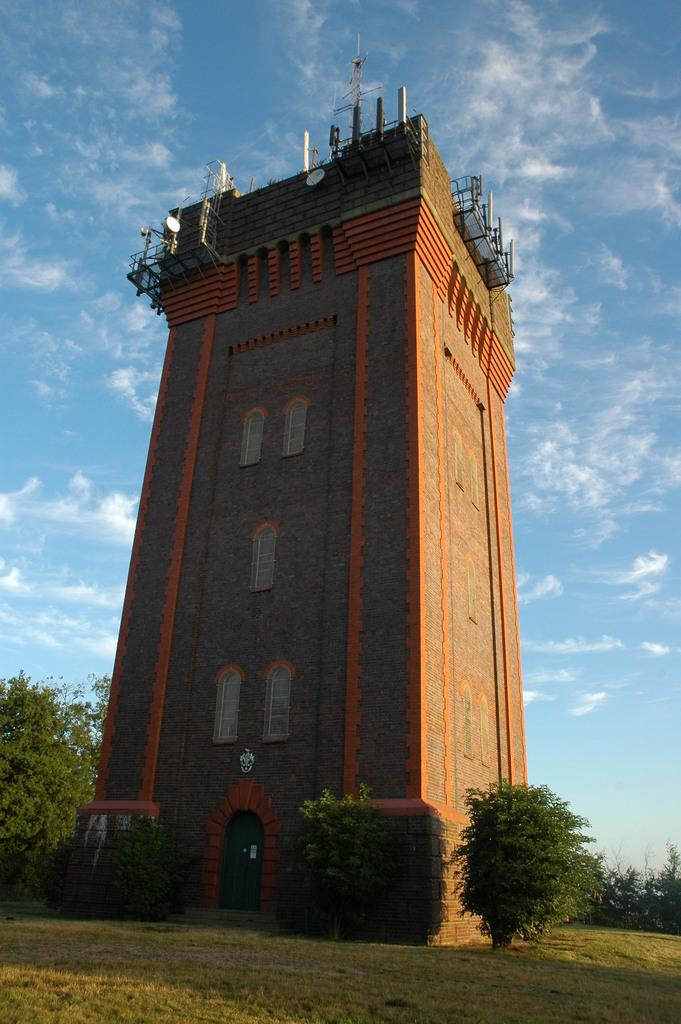What is the main structure in the middle of the image? There is a building in the middle of the image. What can be seen around the building? Trees are present around the building. What feature is on top of the building? There are towers on top of the building. How would you describe the sky in the image? The sky is cloudy. What type of scent can be smelled coming from the hall in the image? There is no hall present in the image, so it is not possible to determine what scent might be smelled. 